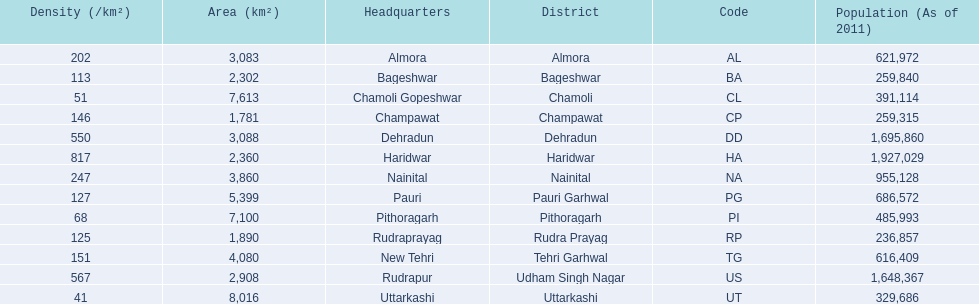What are the names of all the districts? Almora, Bageshwar, Chamoli, Champawat, Dehradun, Haridwar, Nainital, Pauri Garhwal, Pithoragarh, Rudra Prayag, Tehri Garhwal, Udham Singh Nagar, Uttarkashi. What range of densities do these districts encompass? 202, 113, 51, 146, 550, 817, 247, 127, 68, 125, 151, 567, 41. Which district has a density of 51? Chamoli. 